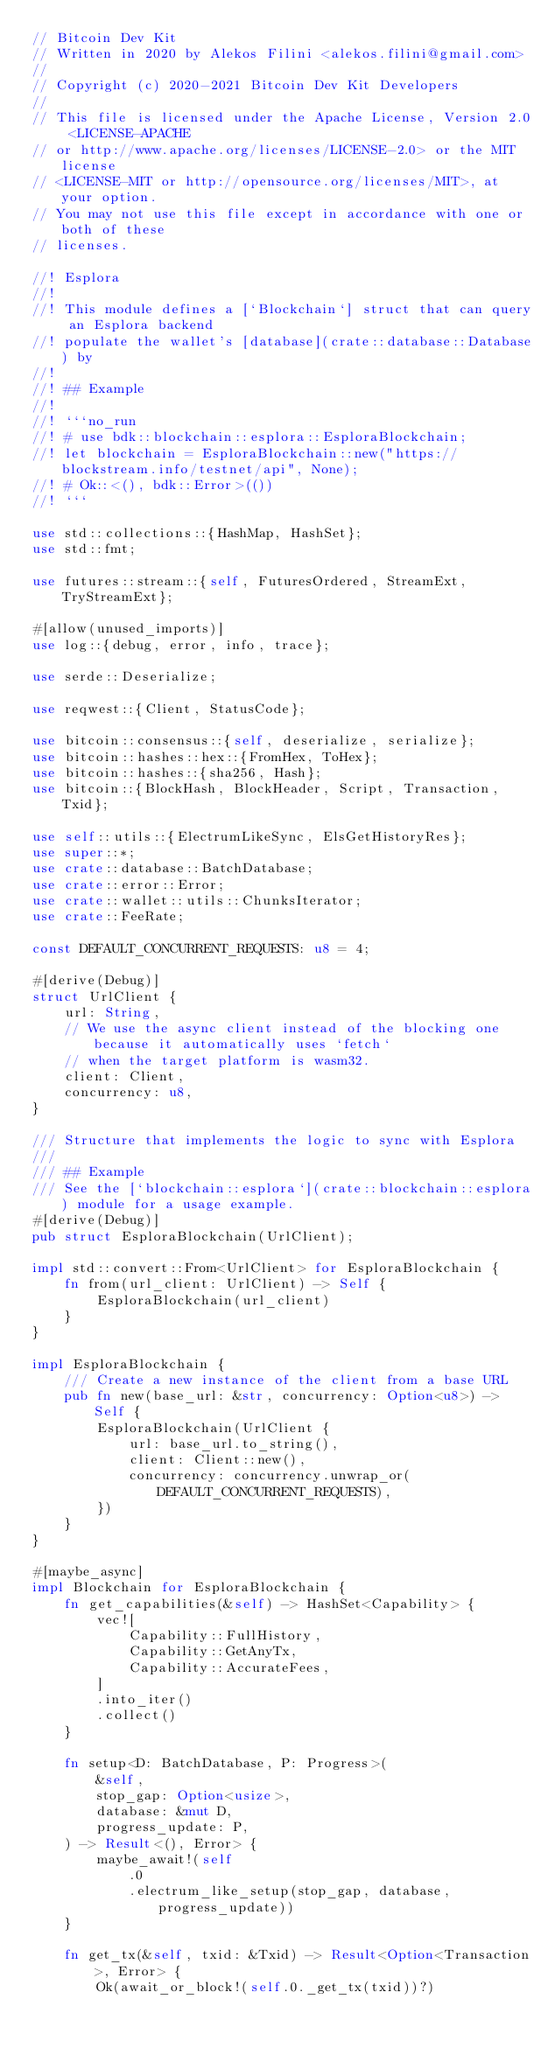<code> <loc_0><loc_0><loc_500><loc_500><_Rust_>// Bitcoin Dev Kit
// Written in 2020 by Alekos Filini <alekos.filini@gmail.com>
//
// Copyright (c) 2020-2021 Bitcoin Dev Kit Developers
//
// This file is licensed under the Apache License, Version 2.0 <LICENSE-APACHE
// or http://www.apache.org/licenses/LICENSE-2.0> or the MIT license
// <LICENSE-MIT or http://opensource.org/licenses/MIT>, at your option.
// You may not use this file except in accordance with one or both of these
// licenses.

//! Esplora
//!
//! This module defines a [`Blockchain`] struct that can query an Esplora backend
//! populate the wallet's [database](crate::database::Database) by
//!
//! ## Example
//!
//! ```no_run
//! # use bdk::blockchain::esplora::EsploraBlockchain;
//! let blockchain = EsploraBlockchain::new("https://blockstream.info/testnet/api", None);
//! # Ok::<(), bdk::Error>(())
//! ```

use std::collections::{HashMap, HashSet};
use std::fmt;

use futures::stream::{self, FuturesOrdered, StreamExt, TryStreamExt};

#[allow(unused_imports)]
use log::{debug, error, info, trace};

use serde::Deserialize;

use reqwest::{Client, StatusCode};

use bitcoin::consensus::{self, deserialize, serialize};
use bitcoin::hashes::hex::{FromHex, ToHex};
use bitcoin::hashes::{sha256, Hash};
use bitcoin::{BlockHash, BlockHeader, Script, Transaction, Txid};

use self::utils::{ElectrumLikeSync, ElsGetHistoryRes};
use super::*;
use crate::database::BatchDatabase;
use crate::error::Error;
use crate::wallet::utils::ChunksIterator;
use crate::FeeRate;

const DEFAULT_CONCURRENT_REQUESTS: u8 = 4;

#[derive(Debug)]
struct UrlClient {
    url: String,
    // We use the async client instead of the blocking one because it automatically uses `fetch`
    // when the target platform is wasm32.
    client: Client,
    concurrency: u8,
}

/// Structure that implements the logic to sync with Esplora
///
/// ## Example
/// See the [`blockchain::esplora`](crate::blockchain::esplora) module for a usage example.
#[derive(Debug)]
pub struct EsploraBlockchain(UrlClient);

impl std::convert::From<UrlClient> for EsploraBlockchain {
    fn from(url_client: UrlClient) -> Self {
        EsploraBlockchain(url_client)
    }
}

impl EsploraBlockchain {
    /// Create a new instance of the client from a base URL
    pub fn new(base_url: &str, concurrency: Option<u8>) -> Self {
        EsploraBlockchain(UrlClient {
            url: base_url.to_string(),
            client: Client::new(),
            concurrency: concurrency.unwrap_or(DEFAULT_CONCURRENT_REQUESTS),
        })
    }
}

#[maybe_async]
impl Blockchain for EsploraBlockchain {
    fn get_capabilities(&self) -> HashSet<Capability> {
        vec![
            Capability::FullHistory,
            Capability::GetAnyTx,
            Capability::AccurateFees,
        ]
        .into_iter()
        .collect()
    }

    fn setup<D: BatchDatabase, P: Progress>(
        &self,
        stop_gap: Option<usize>,
        database: &mut D,
        progress_update: P,
    ) -> Result<(), Error> {
        maybe_await!(self
            .0
            .electrum_like_setup(stop_gap, database, progress_update))
    }

    fn get_tx(&self, txid: &Txid) -> Result<Option<Transaction>, Error> {
        Ok(await_or_block!(self.0._get_tx(txid))?)</code> 